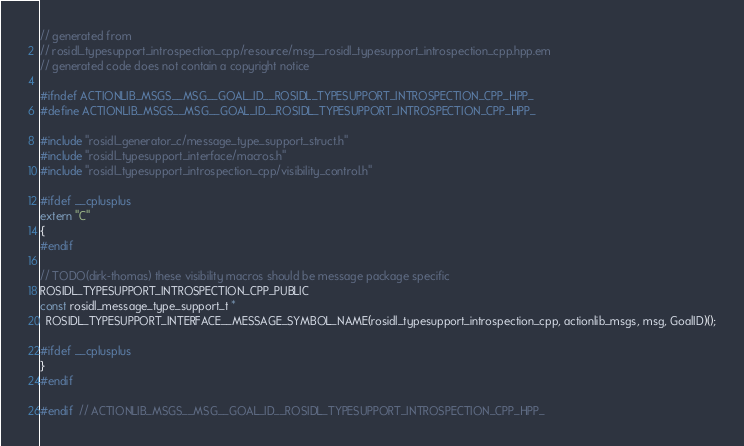Convert code to text. <code><loc_0><loc_0><loc_500><loc_500><_C++_>// generated from
// rosidl_typesupport_introspection_cpp/resource/msg__rosidl_typesupport_introspection_cpp.hpp.em
// generated code does not contain a copyright notice

#ifndef ACTIONLIB_MSGS__MSG__GOAL_ID__ROSIDL_TYPESUPPORT_INTROSPECTION_CPP_HPP_
#define ACTIONLIB_MSGS__MSG__GOAL_ID__ROSIDL_TYPESUPPORT_INTROSPECTION_CPP_HPP_

#include "rosidl_generator_c/message_type_support_struct.h"
#include "rosidl_typesupport_interface/macros.h"
#include "rosidl_typesupport_introspection_cpp/visibility_control.h"

#ifdef __cplusplus
extern "C"
{
#endif

// TODO(dirk-thomas) these visibility macros should be message package specific
ROSIDL_TYPESUPPORT_INTROSPECTION_CPP_PUBLIC
const rosidl_message_type_support_t *
  ROSIDL_TYPESUPPORT_INTERFACE__MESSAGE_SYMBOL_NAME(rosidl_typesupport_introspection_cpp, actionlib_msgs, msg, GoalID)();

#ifdef __cplusplus
}
#endif

#endif  // ACTIONLIB_MSGS__MSG__GOAL_ID__ROSIDL_TYPESUPPORT_INTROSPECTION_CPP_HPP_
</code> 